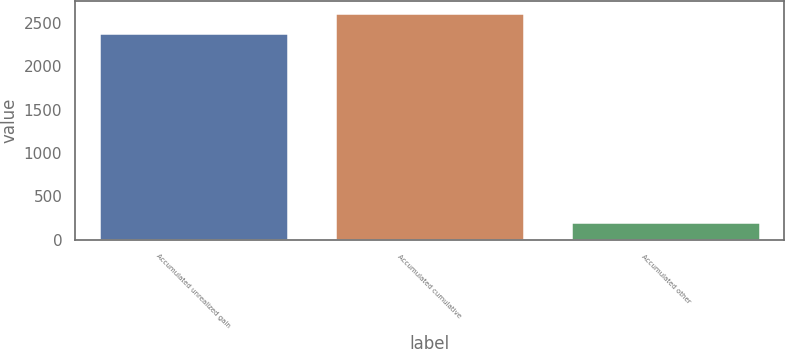<chart> <loc_0><loc_0><loc_500><loc_500><bar_chart><fcel>Accumulated unrealized gain<fcel>Accumulated cumulative<fcel>Accumulated other<nl><fcel>2382<fcel>2620.2<fcel>204<nl></chart> 